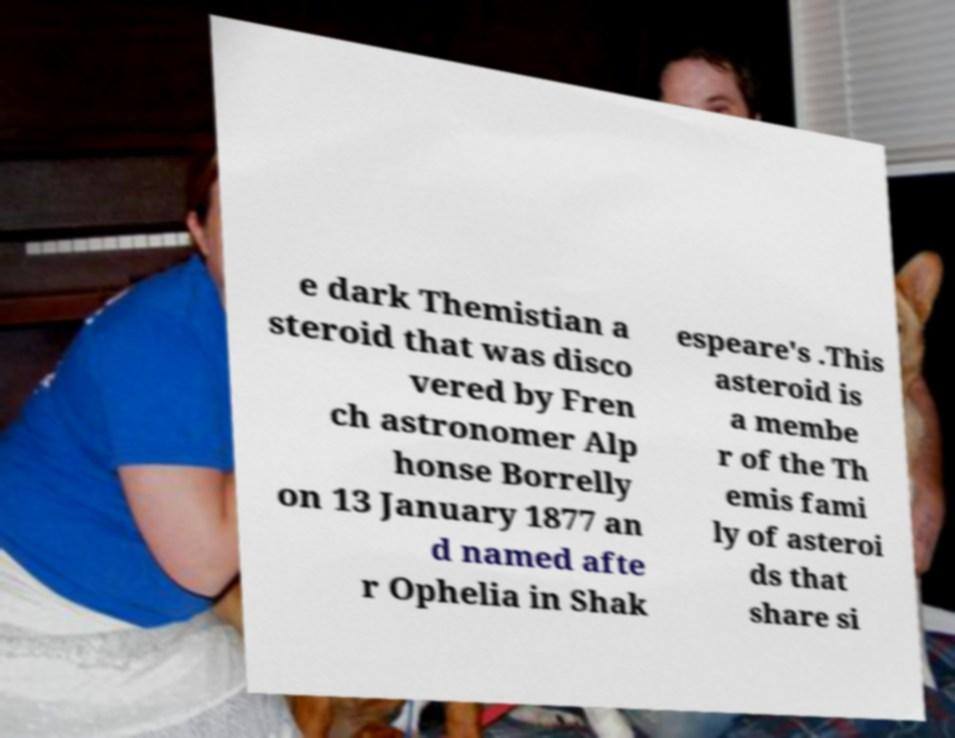What messages or text are displayed in this image? I need them in a readable, typed format. e dark Themistian a steroid that was disco vered by Fren ch astronomer Alp honse Borrelly on 13 January 1877 an d named afte r Ophelia in Shak espeare's .This asteroid is a membe r of the Th emis fami ly of asteroi ds that share si 